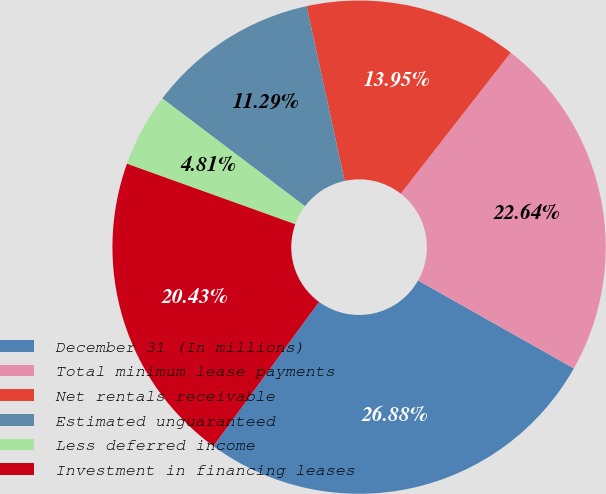<chart> <loc_0><loc_0><loc_500><loc_500><pie_chart><fcel>December 31 (In millions)<fcel>Total minimum lease payments<fcel>Net rentals receivable<fcel>Estimated unguaranteed<fcel>Less deferred income<fcel>Investment in financing leases<nl><fcel>26.88%<fcel>22.64%<fcel>13.95%<fcel>11.29%<fcel>4.81%<fcel>20.43%<nl></chart> 